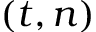Convert formula to latex. <formula><loc_0><loc_0><loc_500><loc_500>( t , n )</formula> 